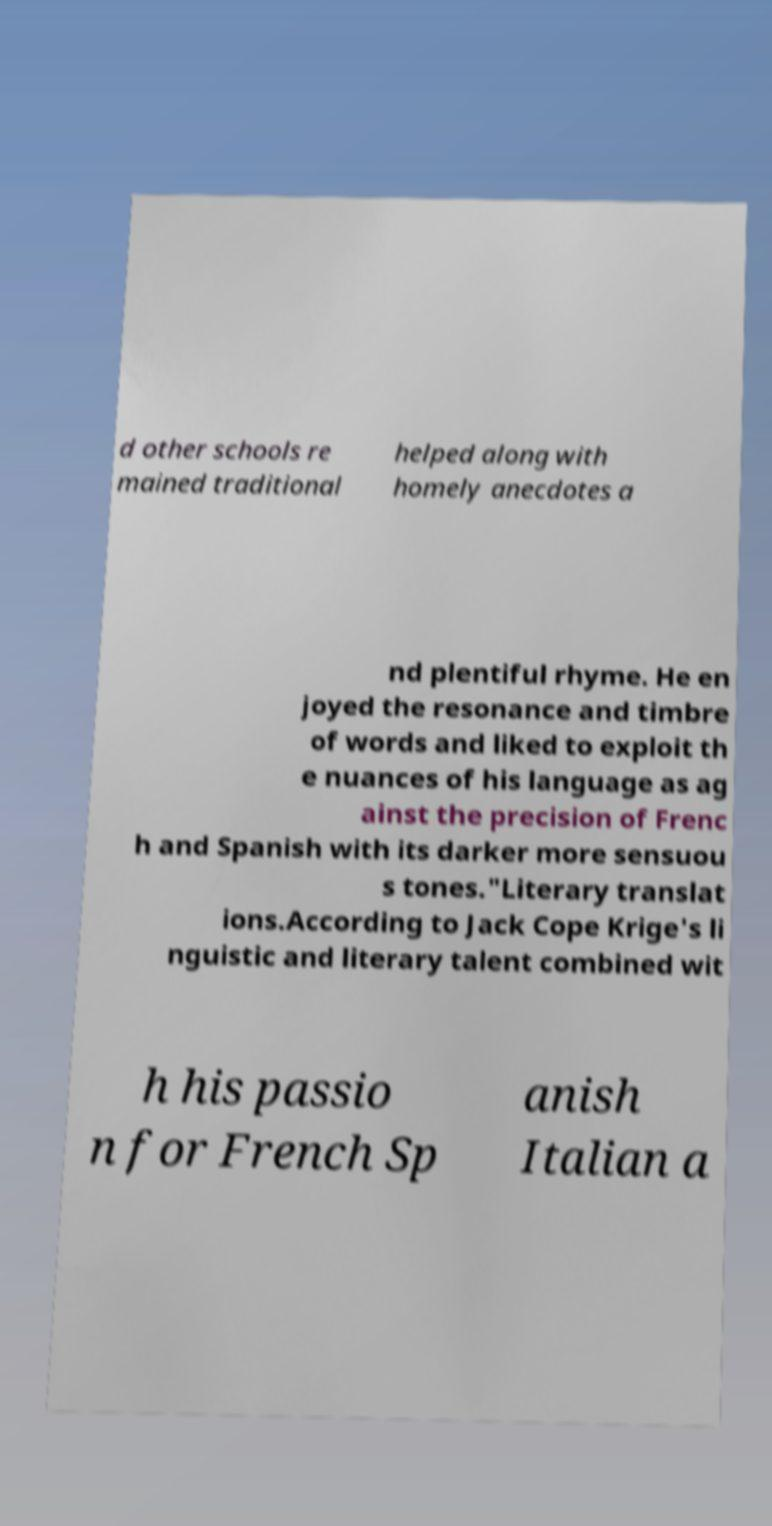There's text embedded in this image that I need extracted. Can you transcribe it verbatim? d other schools re mained traditional helped along with homely anecdotes a nd plentiful rhyme. He en joyed the resonance and timbre of words and liked to exploit th e nuances of his language as ag ainst the precision of Frenc h and Spanish with its darker more sensuou s tones."Literary translat ions.According to Jack Cope Krige's li nguistic and literary talent combined wit h his passio n for French Sp anish Italian a 